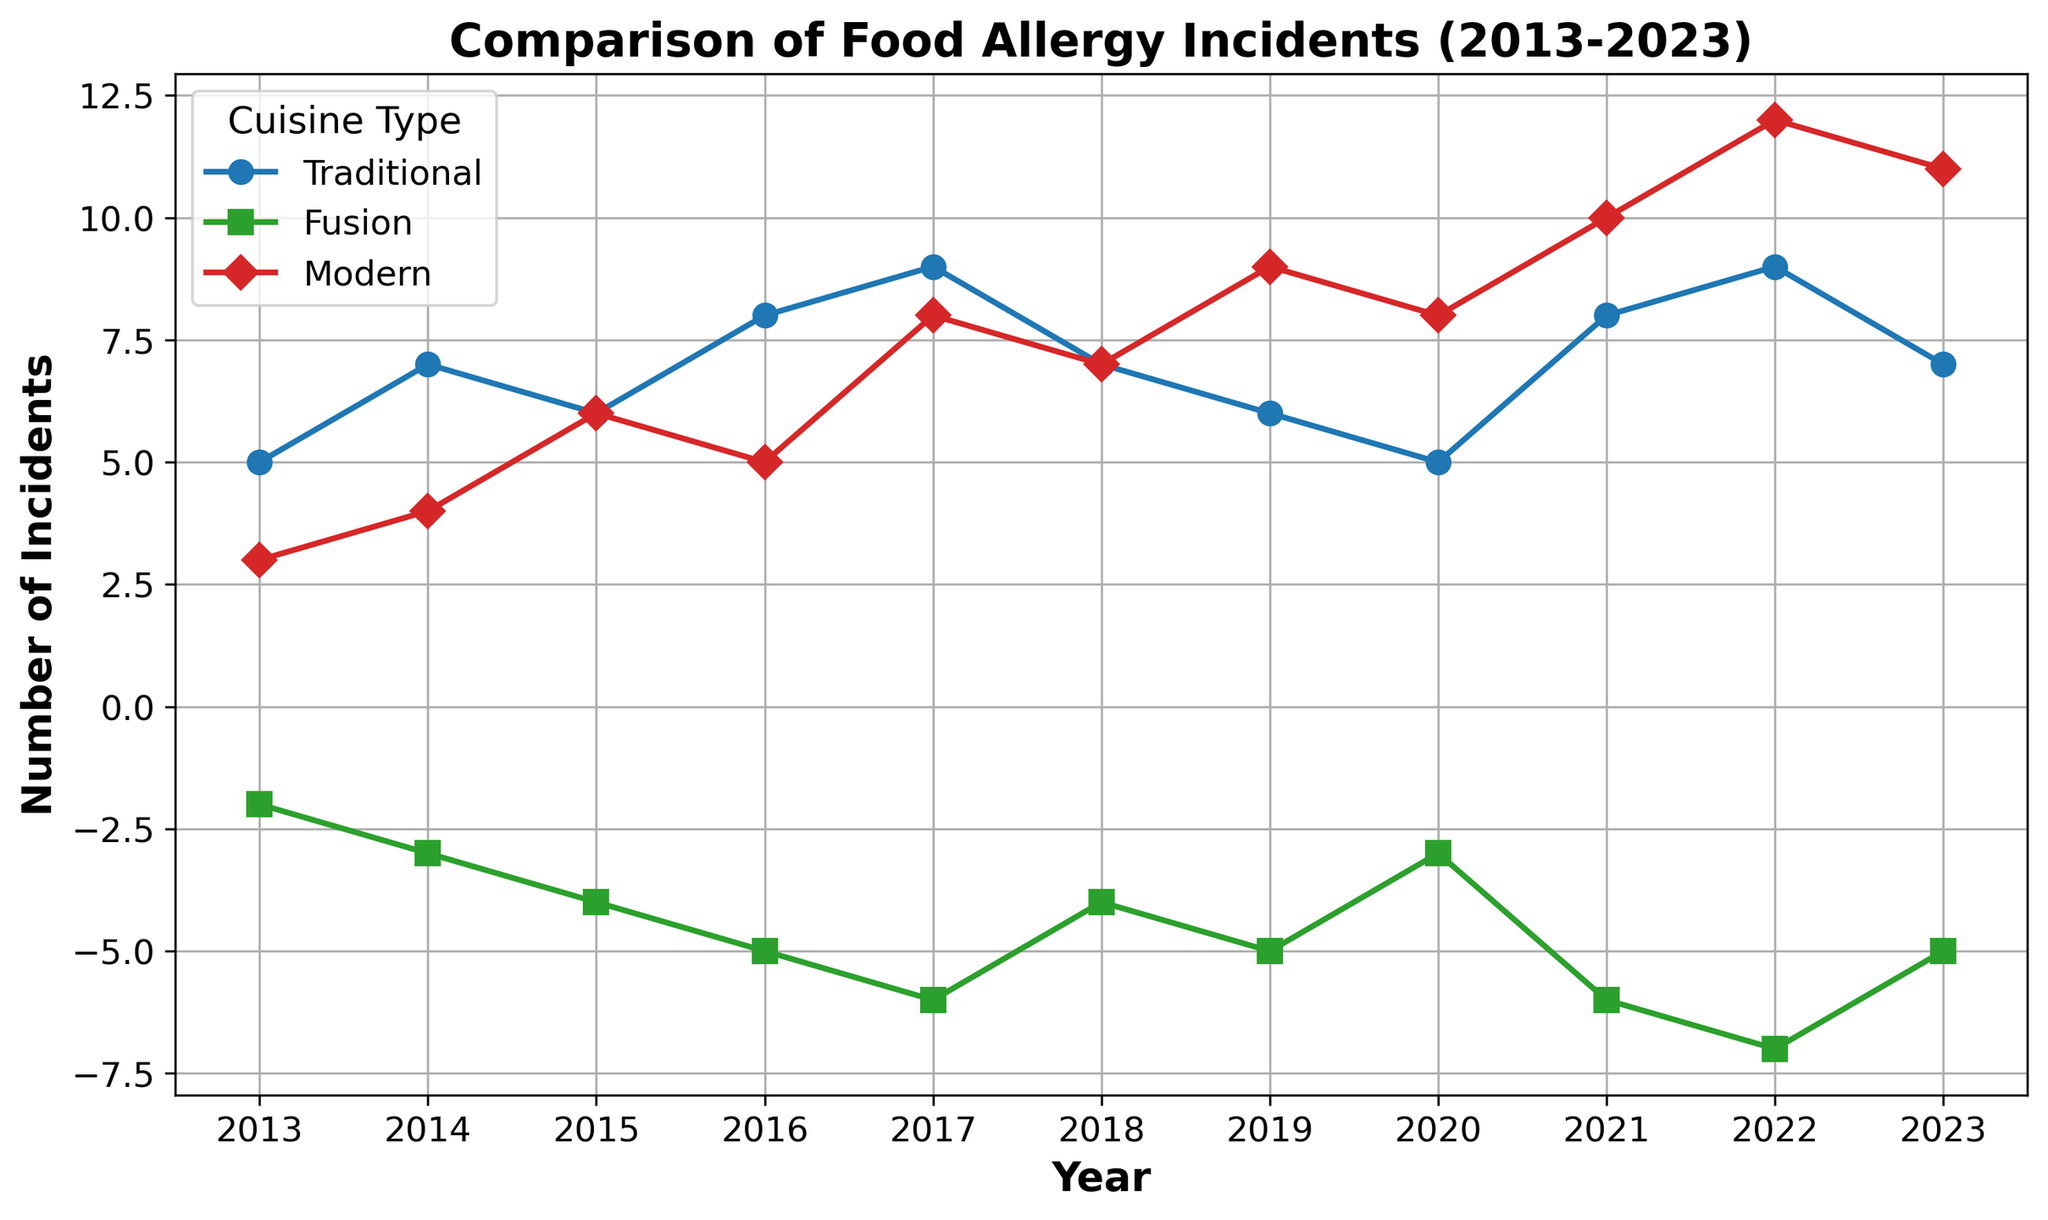What year had the highest number of food allergy incidents linked to traditional dishes? We are looking for the peak point on the blue line. The highest point is at the year 2022.
Answer: 2022 Which cuisine type had a decrease in the number of food allergy incidents over the last decade? By observing the overall trend, the green line represents Fusion dishes, which shows a consistent decrease in incidents.
Answer: Fusion What was the difference in the number of food allergy incidents between Modern and Traditional dishes in 2019? Find the value for Modern and Traditional dishes in 2019 from the red and blue lines respectively. Modern = 9, Traditional = 6, so 9 - 6 = 3.
Answer: 3 In 2017, which cuisine type had the lowest number of food allergy incidents? Comparing the values at 2017, Traditional had 9, Fusion had -6, and Modern had 8. The lowest value is Fusion (-6).
Answer: Fusion What is the average number of food allergy incidents for Modern dishes between 2020 and 2023 inclusive? Summing the values for Modern dishes from 2020 to 2023: 8 + 10 + 12 + 11 = 41. Then divide by the number of values, which is 4. 41 / 4 = 10.25.
Answer: 10.25 How many more food allergy incidents were there in Traditional dishes compared to Fusion dishes in 2022? Traditional dishes in 2022 had 9 incidents, and Fusion dishes had -7 incidents. The difference is 9 - (-7) = 16.
Answer: 16 Which year shows all three cuisine types with a positive number of food allergy incidents? By evaluating each year, the points are positive for all lines during the year 2013.
Answer: 2013 Is there a year when Traditional dishes had fewer incidents than Fusion dishes? Reviewing the data on the graph, there is no year where Traditional (blue) has fewer incidents than Fusion (green).
Answer: No In what year did food allergy incidents in Fusion dishes start being consistently negative? Observing the green line, incidents turned negative and stayed that way from the year 2013.
Answer: 2013 Compare the trend of allergy incidents between Traditional and Modern dishes. Which one shows increasing trends over the decade? Observing both lines, Modern (red) shows a more consistent increasing trend compared to Traditional (blue), which has fluctuations.
Answer: Modern 